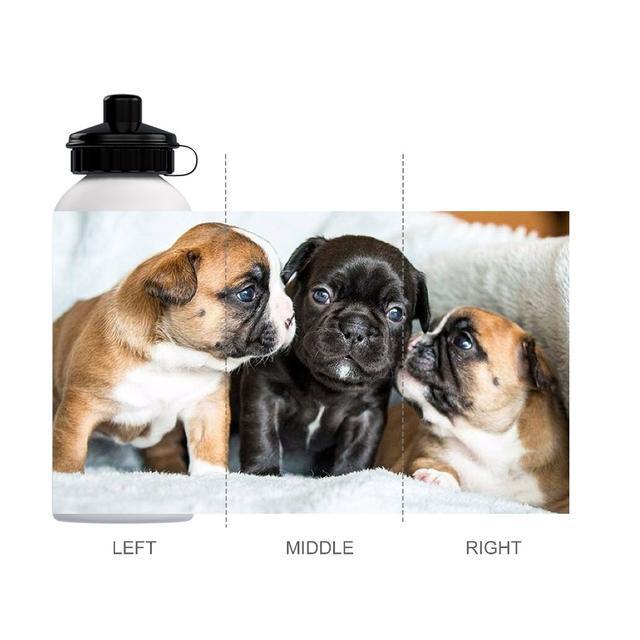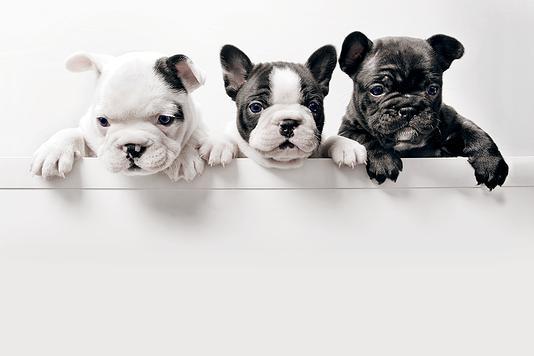The first image is the image on the left, the second image is the image on the right. Evaluate the accuracy of this statement regarding the images: "One of the images features three dogs with their front limbs draped over a horizontal edge.". Is it true? Answer yes or no. Yes. The first image is the image on the left, the second image is the image on the right. Assess this claim about the two images: "Each image shows a horizontal row of three flat-faced dogs, and the right image shows the dogs leaning on a white ledge.". Correct or not? Answer yes or no. Yes. 